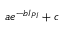<formula> <loc_0><loc_0><loc_500><loc_500>a e ^ { - b I _ { P I } } + c</formula> 